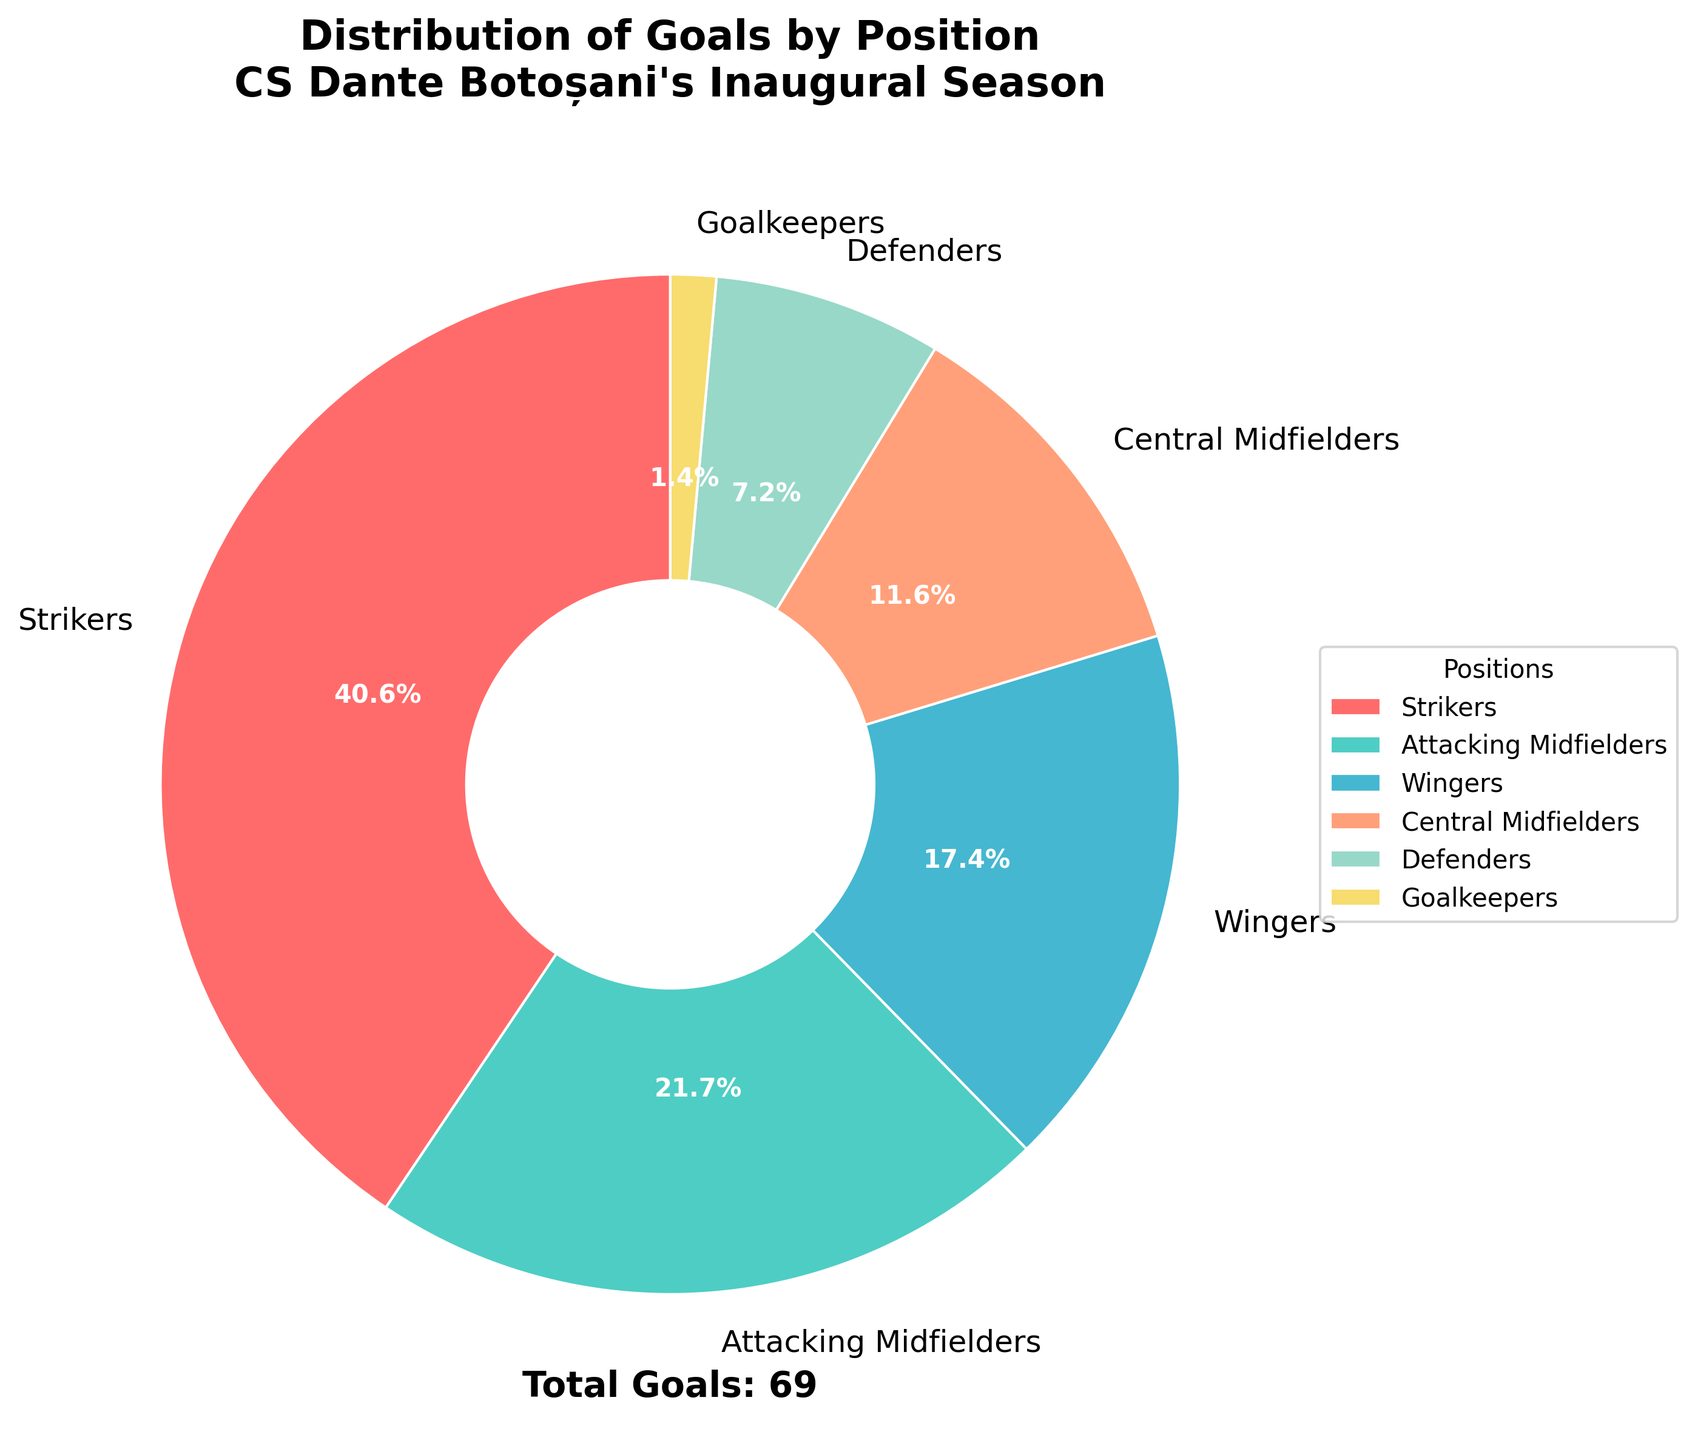What's the largest slice in the pie chart? To find the largest slice, we need to look for the position that has the highest percentage of goals. In the pie chart, this corresponds to the "Strikers" segment.
Answer: Strikers Which position scored the least number of goals? To find the position with the least number of goals, examine the smallest slice in the pie chart. The smallest slice corresponds to the "Goalkeepers" segment.
Answer: Goalkeepers How many goals were scored by Central Midfielders and Defenders combined? We need to sum the goals scored by Central Midfielders and Defenders. According to the chart, Central Midfielders scored 8 and Defenders scored 5. So, 8 + 5 = 13 goals.
Answer: 13 What percent of total goals were scored by Attacking Midfielders? The pie chart shows the percentage of goals for each position. The slice for Attacking Midfielders is labeled with its percentage, which is 22.7%.
Answer: 22.7% Which positions combined scored more goals than Wingers? Wingers scored 12 goals. We look for groups of other positions whose combined goal totals exceed this amount. For example, Central Midfielders (8 goals) and Defenders (5 goals) together scored 13 goals, which is greater than 12. Also, Goalkeepers (1 goal) and Central Midfielders (8 goals) combined scored 9 goals, plus another position like Defenders (5 goals) totals 14 goals.
Answer: Central Midfielders and Defenders Which slice represents the 'Strikers' in terms of color? In the pie chart, the slice representing 'Strikers' is colored in red.
Answer: Red What is the numeric difference between the goals scored by Strikers and by Defenders? By referring to the pie chart, we note that Strikers scored 28 goals and Defenders scored 5 goals. The difference, therefore, is 28 - 5 = 23 goals.
Answer: 23 If we consider only the field positions (excluding Goalkeepers), what's the average number of goals scored per position? Excluding Goalkeepers, the field positions are Strikers, Attacking Midfielders, Wingers, Central Midfielders, and Defenders. Their goal counts are 28, 15, 12, 8, and 5, respectively. First, calculate the total goals: 28 + 15 + 12 + 8 + 5 = 68. There are 5 field positions, so the average is 68 / 5 = 13.6 goals per position.
Answer: 13.6 What percentage of the total goals were scored by positions other than Strikers? First, note that Strikers scored 28 goals out of the total 69 goals. The total percentage is 100%. The percentage goals scored by positions other than Strikers is 100% - percentage scored by Strikers (40.6%). So, 100 - 40.6 = 59.4%.
Answer: 59.4% Which position, apart from Strikers, scored the highest number of goals? Excluding the Strikers position, we compare the goal counts of the remaining positions. Attacking Midfielders scored 15 goals, which is the highest among them.
Answer: Attacking Midfielders 